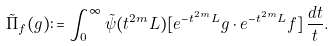Convert formula to latex. <formula><loc_0><loc_0><loc_500><loc_500>\tilde { \Pi } _ { f } ( g ) \colon = \int _ { 0 } ^ { \infty } \tilde { \psi } ( t ^ { 2 m } L ) [ e ^ { - t ^ { 2 m } L } g \cdot e ^ { - t ^ { 2 m } L } f ] \, \frac { d t } { t } .</formula> 